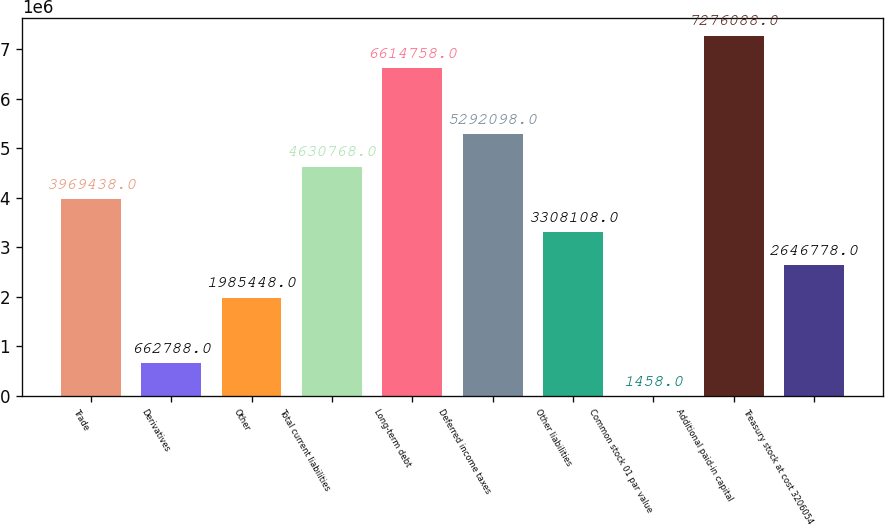<chart> <loc_0><loc_0><loc_500><loc_500><bar_chart><fcel>Trade<fcel>Derivatives<fcel>Other<fcel>Total current liabilities<fcel>Long-term debt<fcel>Deferred income taxes<fcel>Other liabilities<fcel>Common stock 01 par value<fcel>Additional paid-in capital<fcel>Treasury stock at cost 3206054<nl><fcel>3.96944e+06<fcel>662788<fcel>1.98545e+06<fcel>4.63077e+06<fcel>6.61476e+06<fcel>5.2921e+06<fcel>3.30811e+06<fcel>1458<fcel>7.27609e+06<fcel>2.64678e+06<nl></chart> 